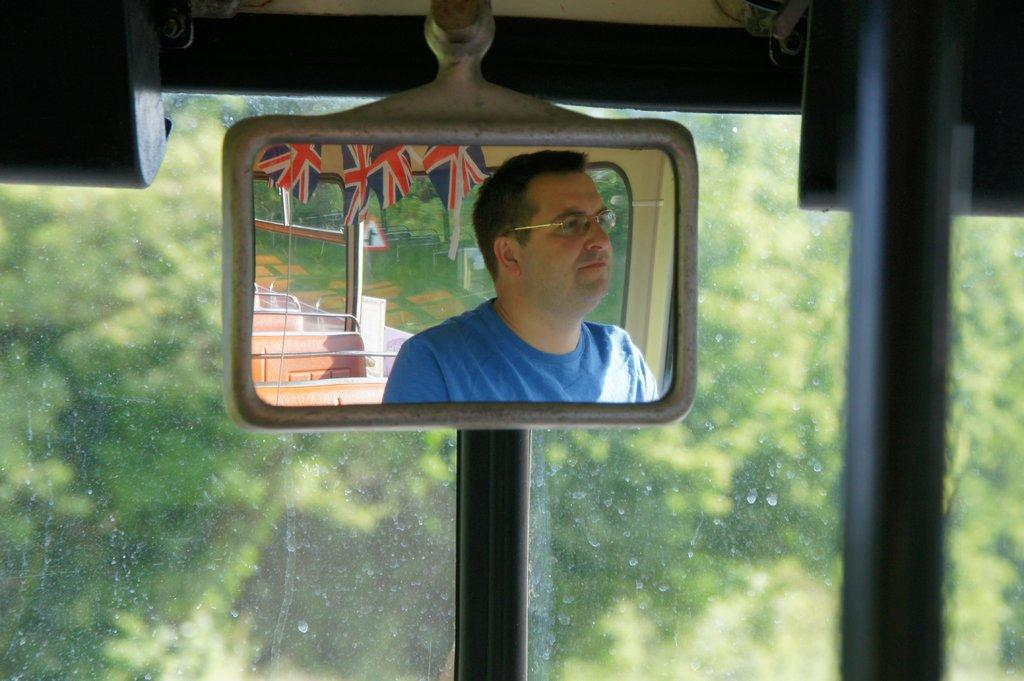What is being reflected in the image? There is a reflection of a person in the image. What can be seen in the reflection besides the person? Seats and flags are visible in the reflection. What is the surface that the reflection is on? The reflection is on a mirror. Where is the mirror located? The mirror is inside a vehicle. What is visible in the background of the image? There is glass and trees in the background of the image. What type of grain is being harvested in the image? There is no grain or harvesting activity present in the image. What is the son of the person in the reflection doing in the image? There is no son or additional person present in the image besides the reflection of the person. 